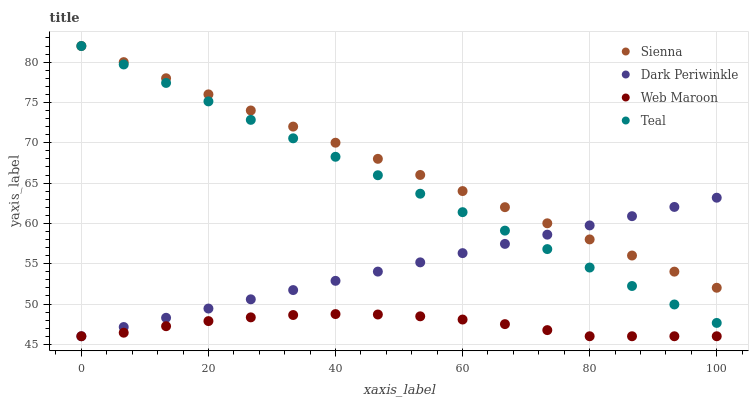Does Web Maroon have the minimum area under the curve?
Answer yes or no. Yes. Does Sienna have the maximum area under the curve?
Answer yes or no. Yes. Does Dark Periwinkle have the minimum area under the curve?
Answer yes or no. No. Does Dark Periwinkle have the maximum area under the curve?
Answer yes or no. No. Is Dark Periwinkle the smoothest?
Answer yes or no. Yes. Is Web Maroon the roughest?
Answer yes or no. Yes. Is Web Maroon the smoothest?
Answer yes or no. No. Is Dark Periwinkle the roughest?
Answer yes or no. No. Does Web Maroon have the lowest value?
Answer yes or no. Yes. Does Teal have the lowest value?
Answer yes or no. No. Does Teal have the highest value?
Answer yes or no. Yes. Does Dark Periwinkle have the highest value?
Answer yes or no. No. Is Web Maroon less than Teal?
Answer yes or no. Yes. Is Sienna greater than Web Maroon?
Answer yes or no. Yes. Does Dark Periwinkle intersect Web Maroon?
Answer yes or no. Yes. Is Dark Periwinkle less than Web Maroon?
Answer yes or no. No. Is Dark Periwinkle greater than Web Maroon?
Answer yes or no. No. Does Web Maroon intersect Teal?
Answer yes or no. No. 